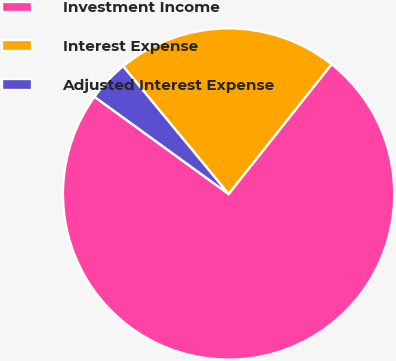<chart> <loc_0><loc_0><loc_500><loc_500><pie_chart><fcel>Investment Income<fcel>Interest Expense<fcel>Adjusted Interest Expense<nl><fcel>74.31%<fcel>21.66%<fcel>4.03%<nl></chart> 